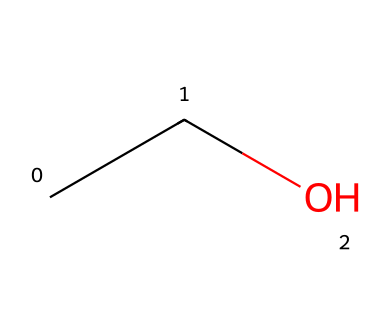What is the molecular formula of this compound? The SMILES representation "CCO" indicates the presence of two carbon atoms (C) and six hydrogen atoms (H), and one oxygen atom (O). Therefore, we can derive the molecular formula as C2H6O.
Answer: C2H6O How many carbon atoms are present in this structure? From the SMILES "CCO," we see that there are two consecutive carbon atoms (C), indicating the number of carbon atoms.
Answer: 2 What type of bonding exists between the carbon and oxygen atoms? The presence of a single bond between carbon and oxygen can be inferred from the structure where the oxygen is connected to one carbon atom. In general, such bonds are classified as sigma bonds.
Answer: sigma bond What characteristic property of ethanol makes it suitable for sports drinks? Ethanol's ability to provide a quick source of energy due to its caloric density and rapid absorption makes it suitable for hydration and energy replenishment during sports activities.
Answer: energy source Is the given compound considered hydrophilic or hydrophobic? The presence of -OH (hydroxyl) group in the ethanol structure indicates that it can interact with water, making it hydrophilic.
Answer: hydrophilic What type of organic compound is ethanol classified as? Ethanol, represented by the SMILES "CCO," is classified as an aliphatic alcohol due to the presence of a hydroxyl group (-OH) attached to a saturated carbon chain.
Answer: alcohol 